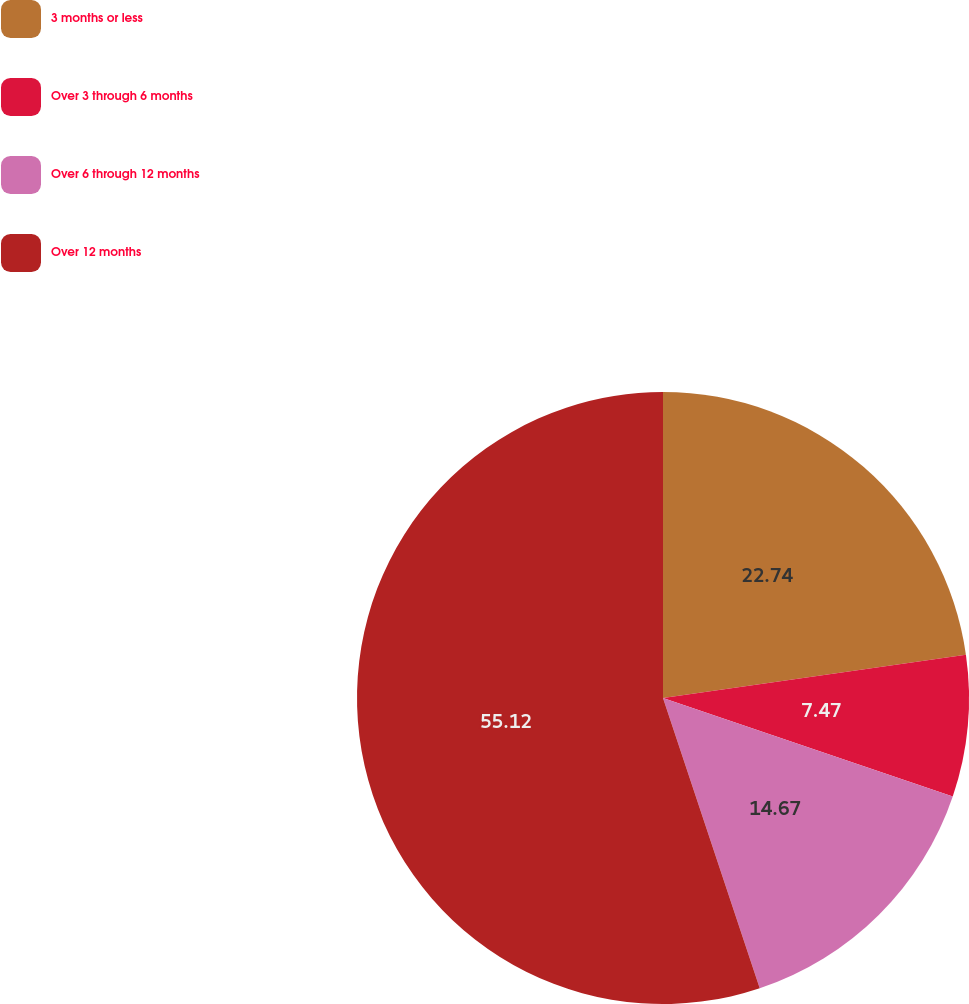<chart> <loc_0><loc_0><loc_500><loc_500><pie_chart><fcel>3 months or less<fcel>Over 3 through 6 months<fcel>Over 6 through 12 months<fcel>Over 12 months<nl><fcel>22.74%<fcel>7.47%<fcel>14.67%<fcel>55.12%<nl></chart> 